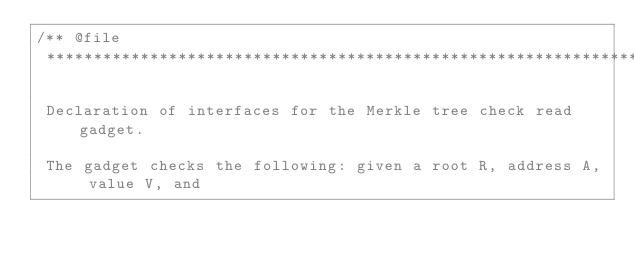Convert code to text. <code><loc_0><loc_0><loc_500><loc_500><_C++_>/** @file
 *****************************************************************************

 Declaration of interfaces for the Merkle tree check read gadget.

 The gadget checks the following: given a root R, address A, value V, and</code> 